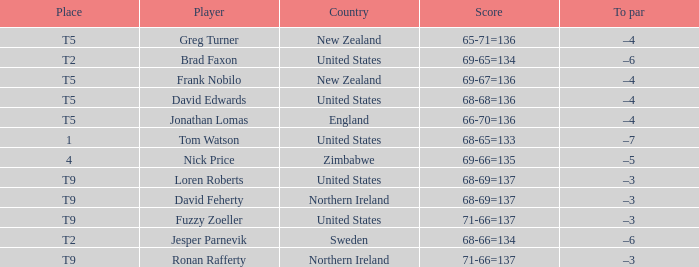Who is the golfer that golfs for Northern Ireland? David Feherty, Ronan Rafferty. 